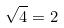<formula> <loc_0><loc_0><loc_500><loc_500>\sqrt { 4 } = 2</formula> 